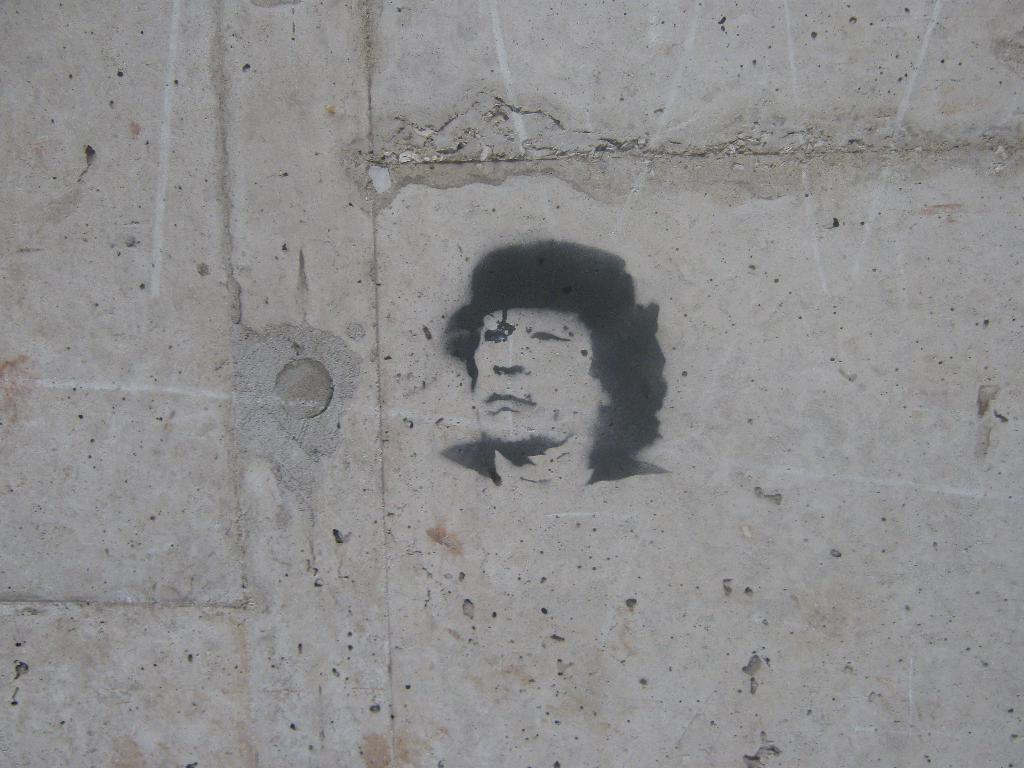What is the main subject in the center of the image? There is a painting on the wall in the center of the image. Can you describe the painting? Unfortunately, the facts provided do not include a description of the painting. What is the background of the image? The background of the image is not mentioned in the provided facts. How many people are sitting on the seat in the image? There is no mention of a seat or any people in the image, so this question cannot be answered. 